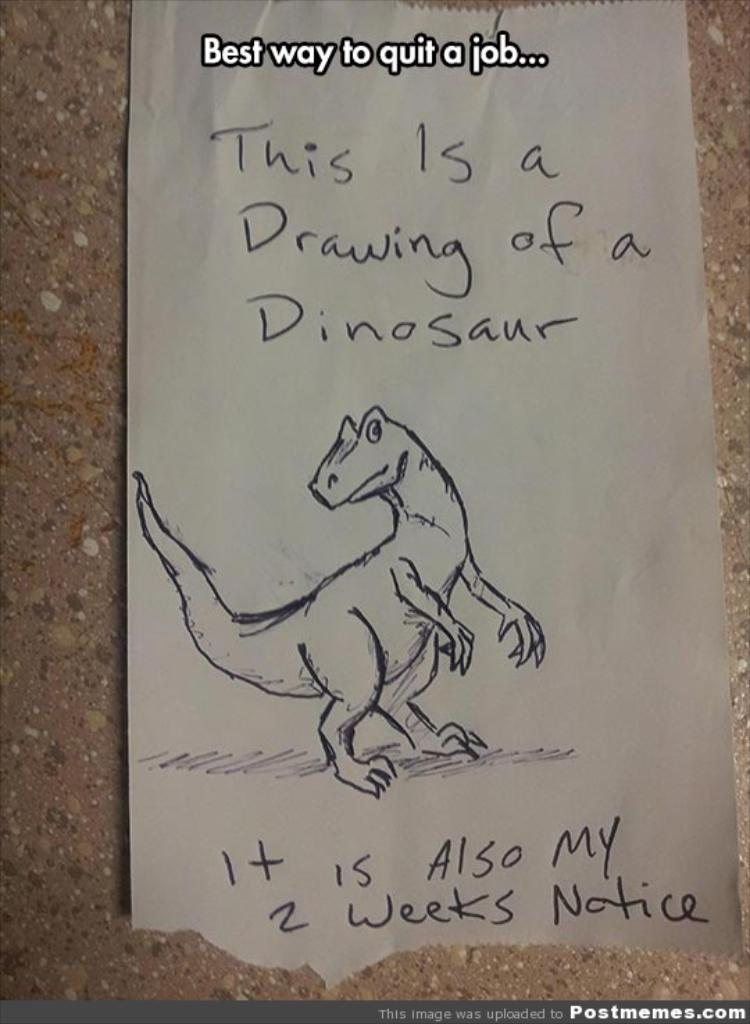What is the main subject of the image? There is a picture of a dinosaur in the image. What else is present in the image besides the dinosaur? There are letters written on a paper in the image. Can you describe the location of the paper in the image? The paper is on an object. What additional features can be observed in the image? There are watermarks at the top and bottom of the image. How does the camera capture the feeling of the dinosaur in the image? There is no camera present in the image, and the dinosaur is a picture, not a living creature with feelings. 